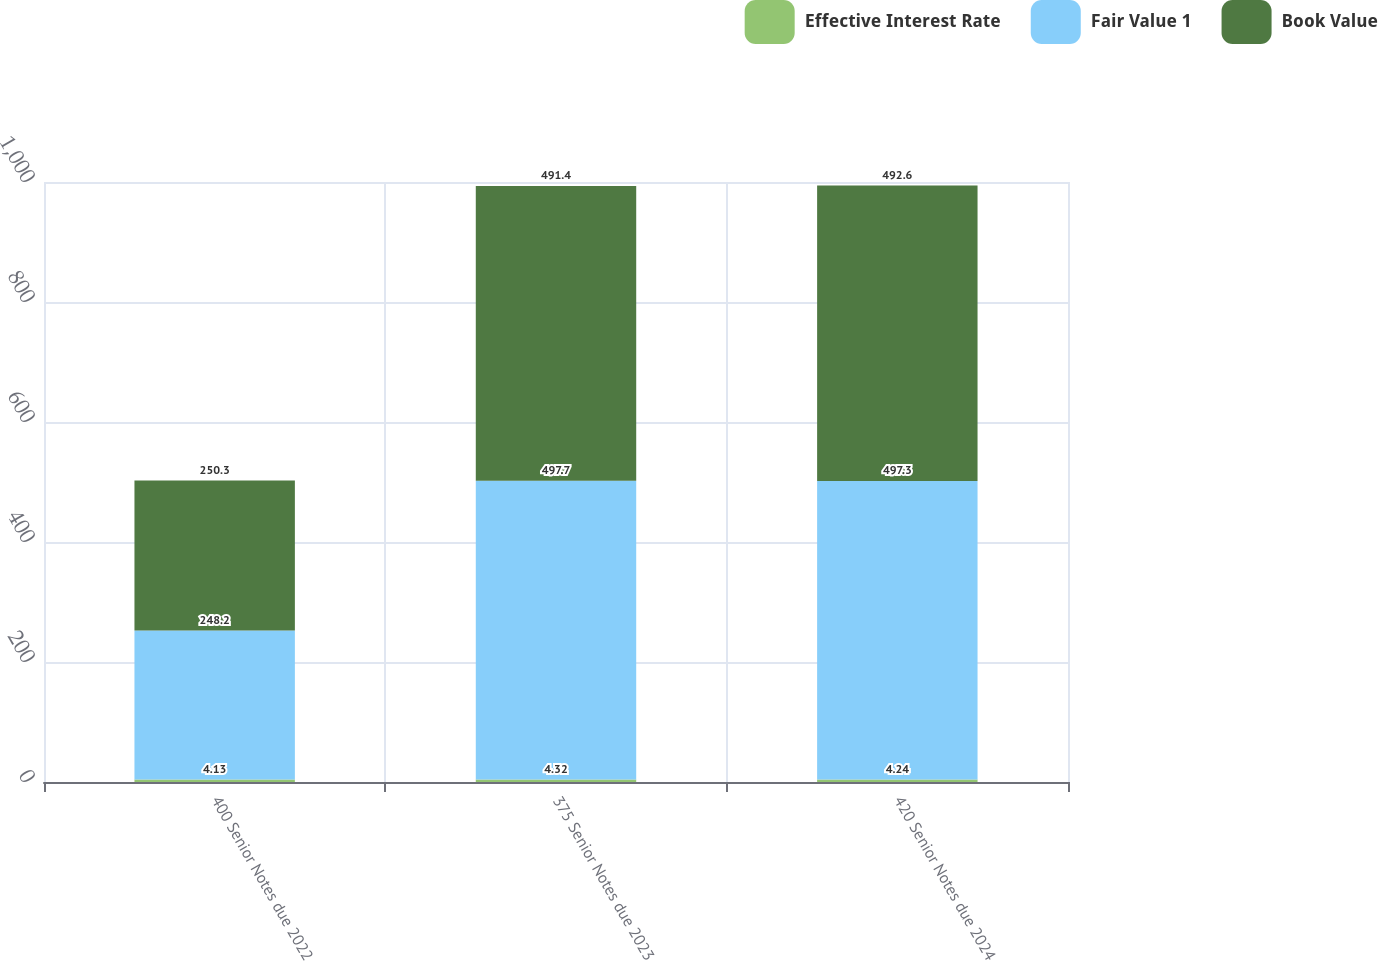<chart> <loc_0><loc_0><loc_500><loc_500><stacked_bar_chart><ecel><fcel>400 Senior Notes due 2022<fcel>375 Senior Notes due 2023<fcel>420 Senior Notes due 2024<nl><fcel>Effective Interest Rate<fcel>4.13<fcel>4.32<fcel>4.24<nl><fcel>Fair Value 1<fcel>248.2<fcel>497.7<fcel>497.3<nl><fcel>Book Value<fcel>250.3<fcel>491.4<fcel>492.6<nl></chart> 